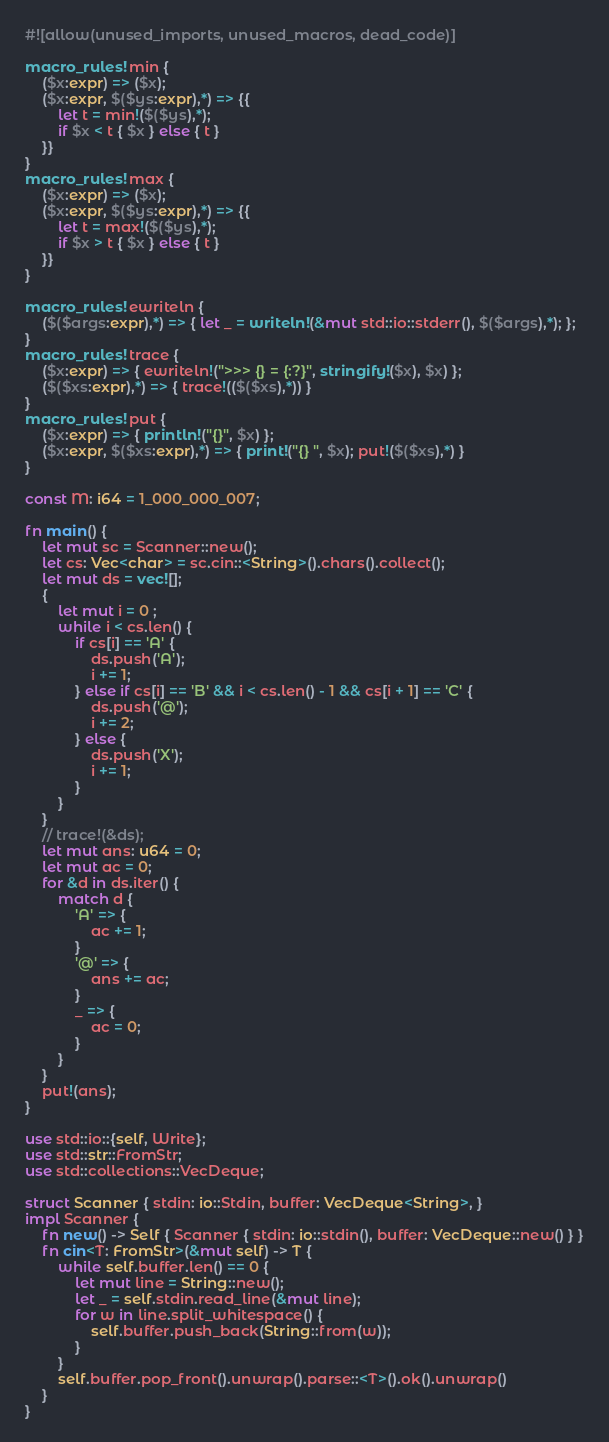Convert code to text. <code><loc_0><loc_0><loc_500><loc_500><_Rust_>#![allow(unused_imports, unused_macros, dead_code)]

macro_rules! min {
    ($x:expr) => ($x);
    ($x:expr, $($ys:expr),*) => {{
        let t = min!($($ys),*);
        if $x < t { $x } else { t }
    }}
}
macro_rules! max {
    ($x:expr) => ($x);
    ($x:expr, $($ys:expr),*) => {{
        let t = max!($($ys),*);
        if $x > t { $x } else { t }
    }}
}

macro_rules! ewriteln {
    ($($args:expr),*) => { let _ = writeln!(&mut std::io::stderr(), $($args),*); };
}
macro_rules! trace {
    ($x:expr) => { ewriteln!(">>> {} = {:?}", stringify!($x), $x) };
    ($($xs:expr),*) => { trace!(($($xs),*)) }
}
macro_rules! put {
    ($x:expr) => { println!("{}", $x) };
    ($x:expr, $($xs:expr),*) => { print!("{} ", $x); put!($($xs),*) }
}

const M: i64 = 1_000_000_007;

fn main() {
    let mut sc = Scanner::new();
    let cs: Vec<char> = sc.cin::<String>().chars().collect();
    let mut ds = vec![];
    {
        let mut i = 0 ;
        while i < cs.len() {
            if cs[i] == 'A' {
                ds.push('A');
                i += 1;
            } else if cs[i] == 'B' && i < cs.len() - 1 && cs[i + 1] == 'C' {
                ds.push('@');
                i += 2;
            } else {
                ds.push('X');
                i += 1;
            }
        }
    }
    // trace!(&ds);
    let mut ans: u64 = 0;
    let mut ac = 0;
    for &d in ds.iter() {
        match d {
            'A' => {
                ac += 1;
            }
            '@' => {
                ans += ac;
            }
            _ => {
                ac = 0;
            }
        }
    }
    put!(ans);
}

use std::io::{self, Write};
use std::str::FromStr;
use std::collections::VecDeque;

struct Scanner { stdin: io::Stdin, buffer: VecDeque<String>, }
impl Scanner {
    fn new() -> Self { Scanner { stdin: io::stdin(), buffer: VecDeque::new() } }
    fn cin<T: FromStr>(&mut self) -> T {
        while self.buffer.len() == 0 {
            let mut line = String::new();
            let _ = self.stdin.read_line(&mut line);
            for w in line.split_whitespace() {
                self.buffer.push_back(String::from(w));
            }
        }
        self.buffer.pop_front().unwrap().parse::<T>().ok().unwrap()
    }
}
</code> 